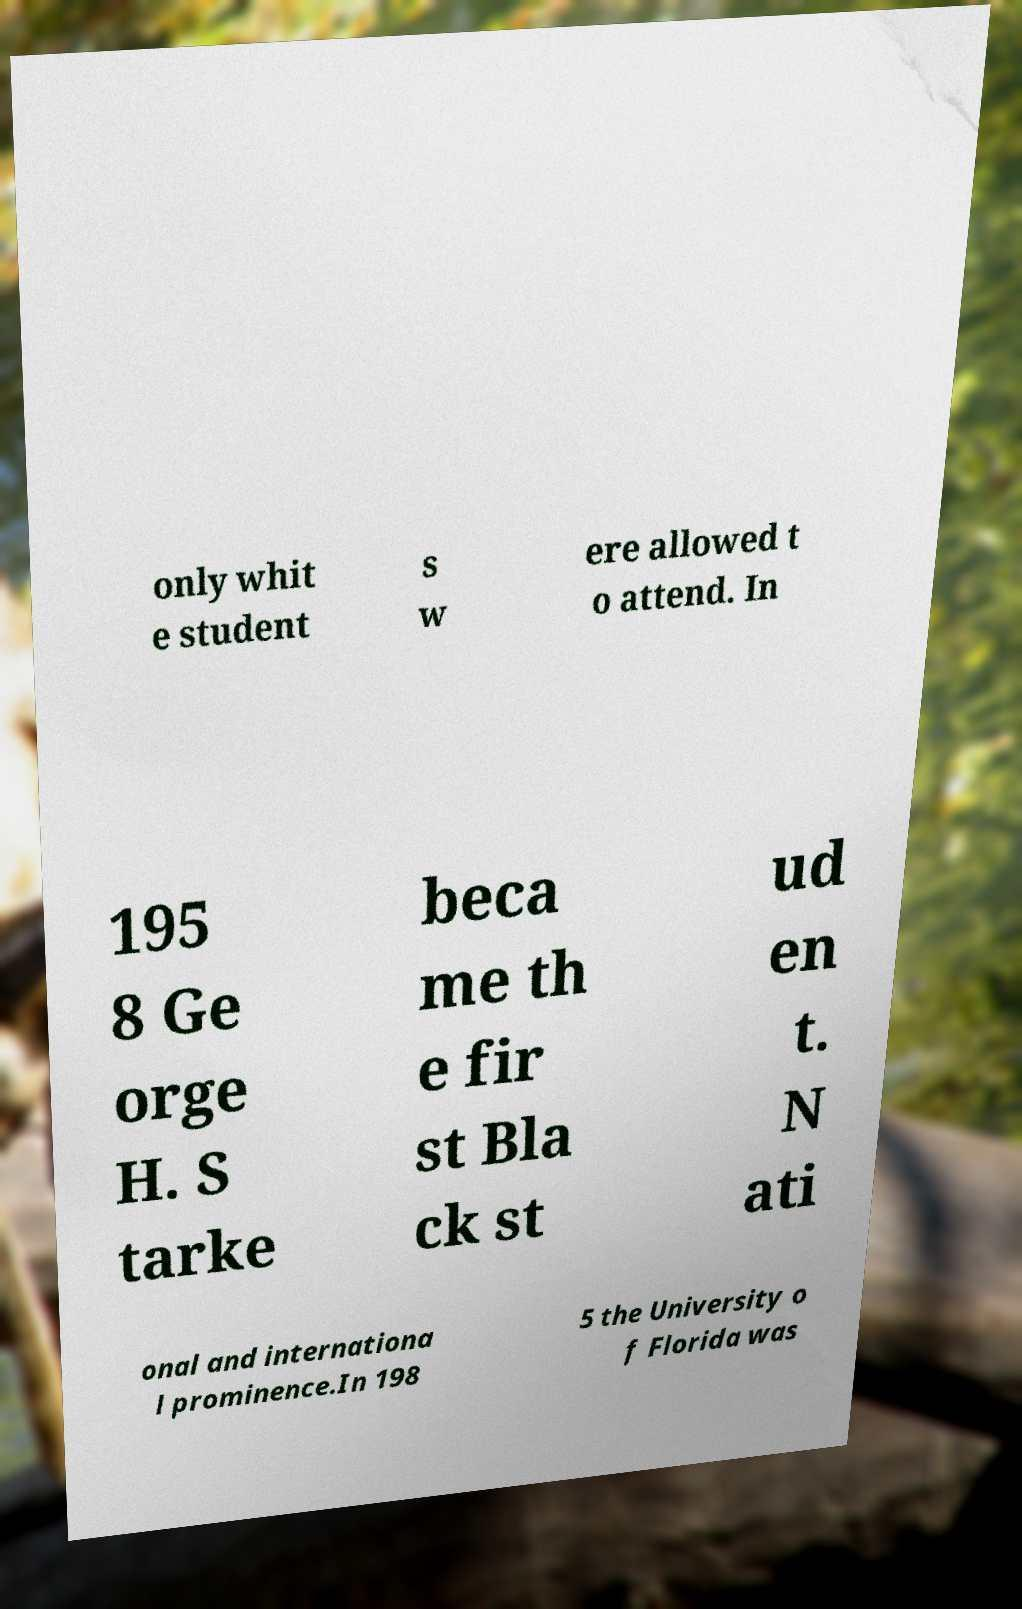There's text embedded in this image that I need extracted. Can you transcribe it verbatim? only whit e student s w ere allowed t o attend. In 195 8 Ge orge H. S tarke beca me th e fir st Bla ck st ud en t. N ati onal and internationa l prominence.In 198 5 the University o f Florida was 